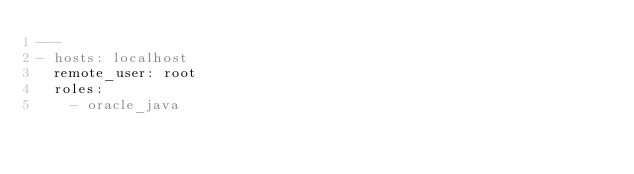<code> <loc_0><loc_0><loc_500><loc_500><_YAML_>---
- hosts: localhost
  remote_user: root
  roles:
    - oracle_java</code> 